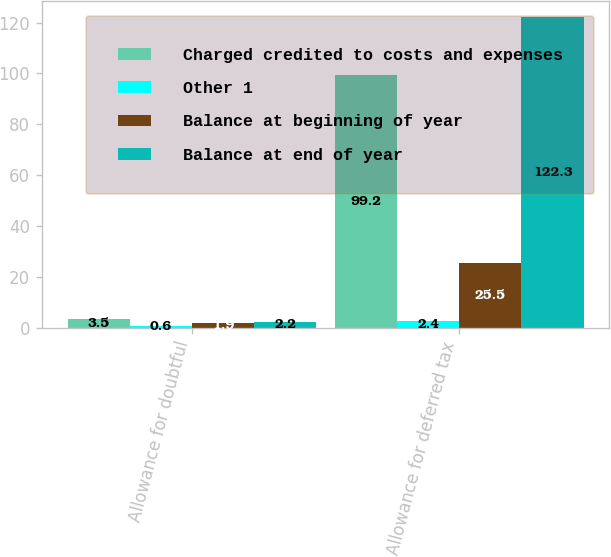<chart> <loc_0><loc_0><loc_500><loc_500><stacked_bar_chart><ecel><fcel>Allowance for doubtful<fcel>Allowance for deferred tax<nl><fcel>Charged credited to costs and expenses<fcel>3.5<fcel>99.2<nl><fcel>Other 1<fcel>0.6<fcel>2.4<nl><fcel>Balance at beginning of year<fcel>1.9<fcel>25.5<nl><fcel>Balance at end of year<fcel>2.2<fcel>122.3<nl></chart> 